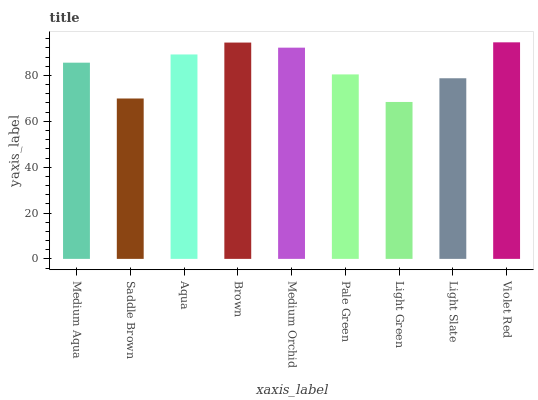Is Light Green the minimum?
Answer yes or no. Yes. Is Violet Red the maximum?
Answer yes or no. Yes. Is Saddle Brown the minimum?
Answer yes or no. No. Is Saddle Brown the maximum?
Answer yes or no. No. Is Medium Aqua greater than Saddle Brown?
Answer yes or no. Yes. Is Saddle Brown less than Medium Aqua?
Answer yes or no. Yes. Is Saddle Brown greater than Medium Aqua?
Answer yes or no. No. Is Medium Aqua less than Saddle Brown?
Answer yes or no. No. Is Medium Aqua the high median?
Answer yes or no. Yes. Is Medium Aqua the low median?
Answer yes or no. Yes. Is Light Slate the high median?
Answer yes or no. No. Is Violet Red the low median?
Answer yes or no. No. 